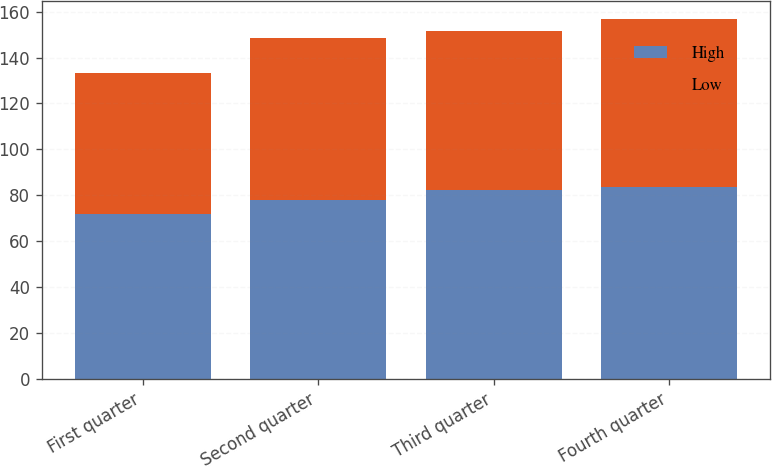<chart> <loc_0><loc_0><loc_500><loc_500><stacked_bar_chart><ecel><fcel>First quarter<fcel>Second quarter<fcel>Third quarter<fcel>Fourth quarter<nl><fcel>High<fcel>71.97<fcel>77.78<fcel>82.4<fcel>83.54<nl><fcel>Low<fcel>61.5<fcel>70.81<fcel>69.02<fcel>73.5<nl></chart> 